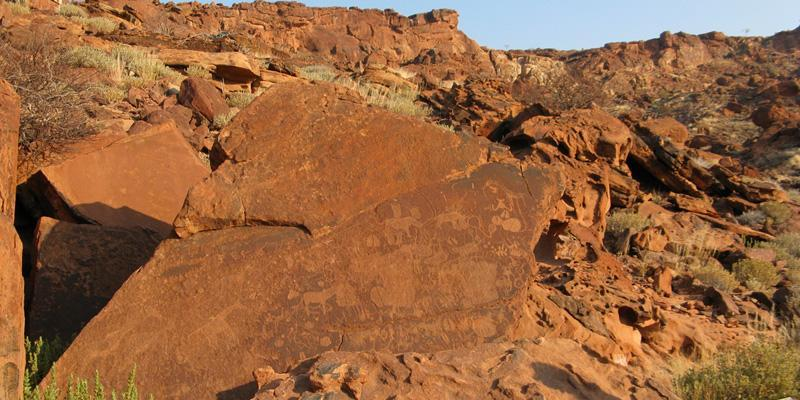How do the environmental conditions contribute to the preservation or degradation of the engravings? The harsh, arid conditions of Namibia have played a significant role in both the preservation and potential degradation of the Twyfelfontein engravings. On one hand, the lack of rain and minimal vegetation growth in the area have helped in preserving the petroglyphs, as erosion from water and root penetration is minimized. The rock surfaces thus remain relatively intact with the engravings still visible after thousands of years.

On the other hand, the extreme temperature fluctuations between scorching days and cold nights can cause the rocks to expand and contract, potentially leading to cracking and surface wear over prolonged periods. Additionally, wind-blown sand can also contribute to the gradual abrasion of the carvings. Therefore, while the arid climate has been generally beneficial for preservation, it also presents challenges that could impact the longevity of the engravings. Can you create a fictional backstory for one of the animals engraved? In a time before time, there was a great lion, revered by the San people as the guardian spirit of the region they called home. This lion, known as Tau-the-Mighty, roamed the plains with a fierce yet noble demeanor, protecting the land's balance and ensuring the circle of life remained undisturbed.

The San believed that Tau-the-Mighty possessed the wisdom of the ancestors and the strength of ten warriors. They would often carve his image into rocks to honor his spirit and seek his protection. Each engraving was accompanied by a prayer, a wish, or a tribute, believing that Tau's spirit would watch over them and guide their hunts.

One particularly severe drought left the land barren and hunts unsuccessful. The San shamans gathered, seeking guidance from Tau-the-Mighty. During a sacred night under a full moon, they performed an elaborate ritual around one of the engravings, dancing and chanting until dawn. Legend says that as the first light of day touched the carving, rains began to fall, and the land blossomed anew, a testament to Tau's enduring guardianship. This story was passed down through generations, ensuring that the spirit of Tau-the-Mighty lived on in every lion engraved, a symbol of hope and resilience for the people. Describe the significance of the smaller engravings surrounding the larger animals. The smaller engravings surrounding the larger animal carvings likely hold their own significance, adding layers of meaning to the central images. These smaller figures might represent the intricate aspects of daily life, the different roles within the community, or even ancillary elements of stories and myths being depicted. In a more practical sense, they could signify the environment in which these larger animals existed, showcasing smaller creatures, plant life, or symbols of resources like water.

These engravings provide a more comprehensive narrative, complementing the dominant figures. They could be illustrating hunting strategies, migration patterns of the animals, or spiritual symbols invoking protection and fortune. Together, the large and small engravings provide a holistic view into the life, beliefs, and environment of the San people, ensuring a fuller understanding of their interaction with the natural world. Can this site be compared to other ancient art sites around the world in terms of its importance and preservation? Yes, Twyfelfontein can be compared to other significant ancient art sites around the world, such as the Lascaux Cave in France, the Chauvet Cave, and the petroglyphs of Valcamonica in Italy, to name a few. Each of these sites holds an important place in our understanding of early human artistic expression, serving as evidence of the cognitive and cultural development of prehistoric societies.

In terms of importance, Twyfelfontein is exceptional for its extensive collection of over 2,000 engravings, one of the largest concentrations in Africa. It showcases not only the artistic skills of the San people but also offers deep insights into their socio-cultural and spiritual life.

As for preservation, Twyfelfontein benefits from its arid climate, which has helped maintain the carvings' visibility over millennia, similar to the conditions that have preserved the petroglyphs in the American Southwest. However, like many ancient sites, it faces challenges from environmental factors and human activity, necessitating ongoing efforts to protect and conserve these cultural treasures for future generations. The significance and resonance of Twyfelfontein in understanding human history make it a truly comparable site to other world-renowned ancient art locations. 